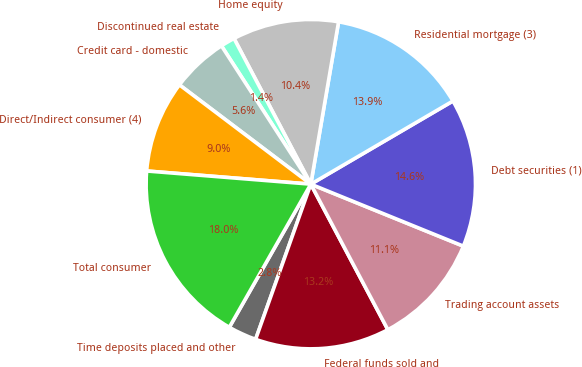Convert chart to OTSL. <chart><loc_0><loc_0><loc_500><loc_500><pie_chart><fcel>Time deposits placed and other<fcel>Federal funds sold and<fcel>Trading account assets<fcel>Debt securities (1)<fcel>Residential mortgage (3)<fcel>Home equity<fcel>Discontinued real estate<fcel>Credit card - domestic<fcel>Direct/Indirect consumer (4)<fcel>Total consumer<nl><fcel>2.8%<fcel>13.19%<fcel>11.11%<fcel>14.57%<fcel>13.88%<fcel>10.42%<fcel>1.41%<fcel>5.57%<fcel>9.03%<fcel>18.04%<nl></chart> 